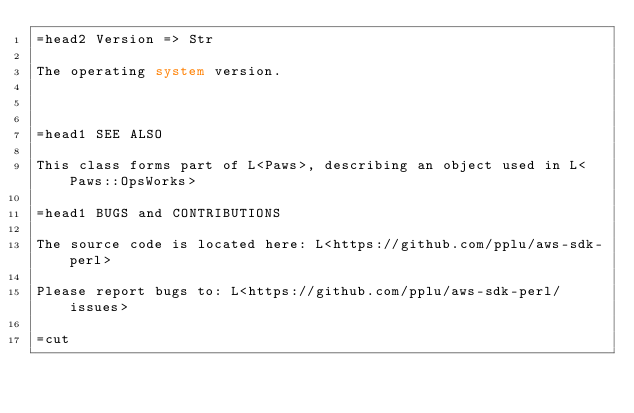Convert code to text. <code><loc_0><loc_0><loc_500><loc_500><_Perl_>=head2 Version => Str

The operating system version.



=head1 SEE ALSO

This class forms part of L<Paws>, describing an object used in L<Paws::OpsWorks>

=head1 BUGS and CONTRIBUTIONS

The source code is located here: L<https://github.com/pplu/aws-sdk-perl>

Please report bugs to: L<https://github.com/pplu/aws-sdk-perl/issues>

=cut

</code> 